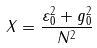Convert formula to latex. <formula><loc_0><loc_0><loc_500><loc_500>X = \frac { \varepsilon _ { 0 } ^ { 2 } + g _ { 0 } ^ { 2 } } { N ^ { 2 } }</formula> 